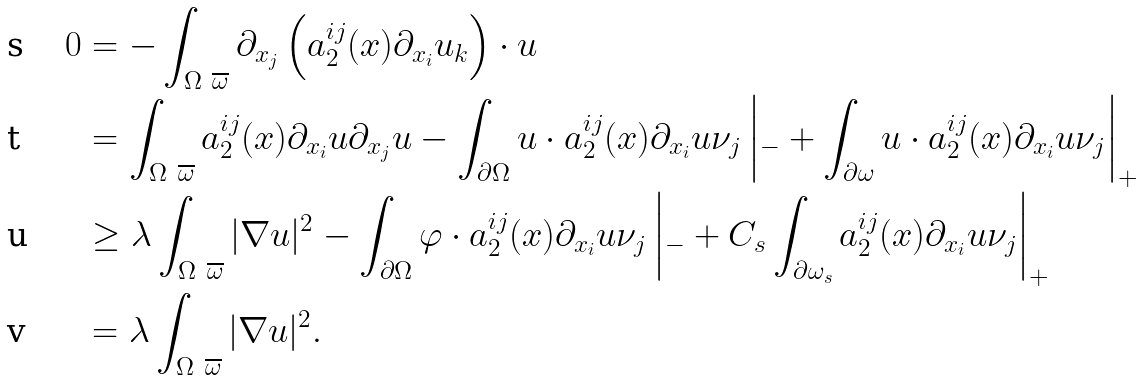<formula> <loc_0><loc_0><loc_500><loc_500>0 & = - \int _ { \Omega \ \overline { \omega } } \partial _ { x _ { j } } \left ( a _ { 2 } ^ { i j } ( x ) \partial _ { x _ { i } } { u _ { k } } \right ) \cdot u \\ & = \int _ { \Omega \ \overline { \omega } } a _ { 2 } ^ { i j } ( x ) \partial _ { x _ { i } } { u } \partial _ { x _ { j } } { u } - \int _ { \partial \Omega } u \cdot a _ { 2 } ^ { i j } ( x ) \partial _ { x _ { i } } { u } \nu _ { j } \left | _ { - } + \int _ { \partial \omega } u \cdot a _ { 2 } ^ { i j } ( x ) \partial _ { x _ { i } } { u } \nu _ { j } \right | _ { + } \\ & \geq \lambda \int _ { \Omega \ \overline { \omega } } | \nabla u | ^ { 2 } - \int _ { \partial \Omega } \varphi \cdot a _ { 2 } ^ { i j } ( x ) \partial _ { x _ { i } } { u } \nu _ { j } \left | _ { - } + C _ { s } \int _ { \partial \omega _ { s } } a _ { 2 } ^ { i j } ( x ) \partial _ { x _ { i } } { u } \nu _ { j } \right | _ { + } \\ & = \lambda \int _ { \Omega \ \overline { \omega } } | \nabla u | ^ { 2 } .</formula> 